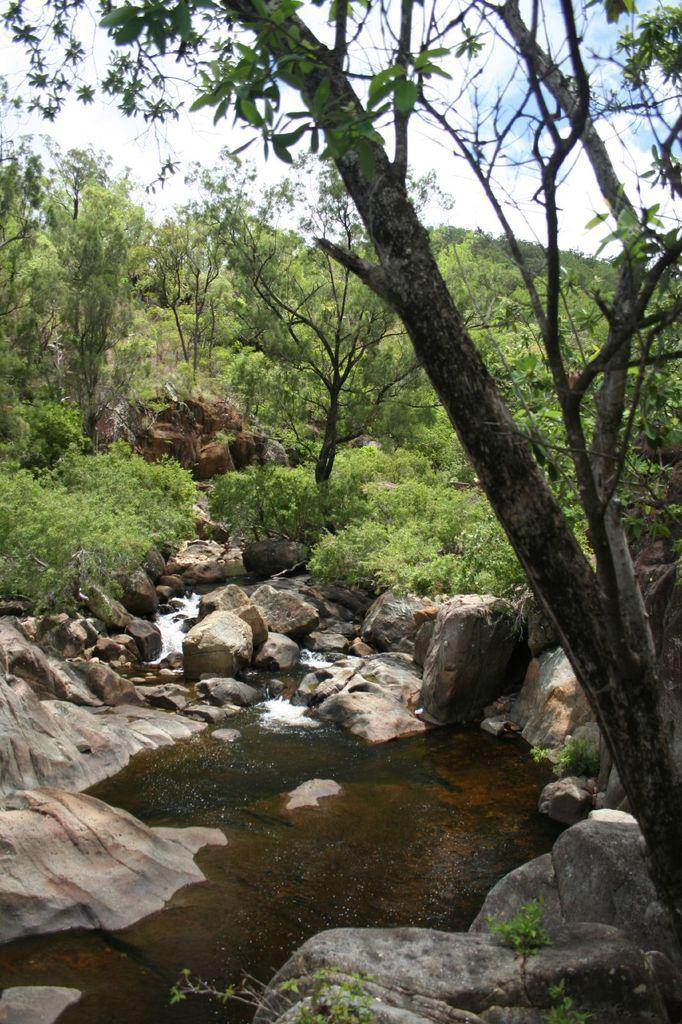What type of vegetation can be seen in the image? There is a group of trees in the image. What other natural elements are present in the image? There are rocks and plants visible in the image. What is the condition of the water in the image? The water is visible in the image, but its condition cannot be determined from the provided facts. What is visible in the sky in the image? The sky is visible in the image and appears cloudy. What type of quartz can be seen in the image? There is no quartz present in the image. Can you spot an owl perched on one of the trees in the image? There is no owl visible in the image. 